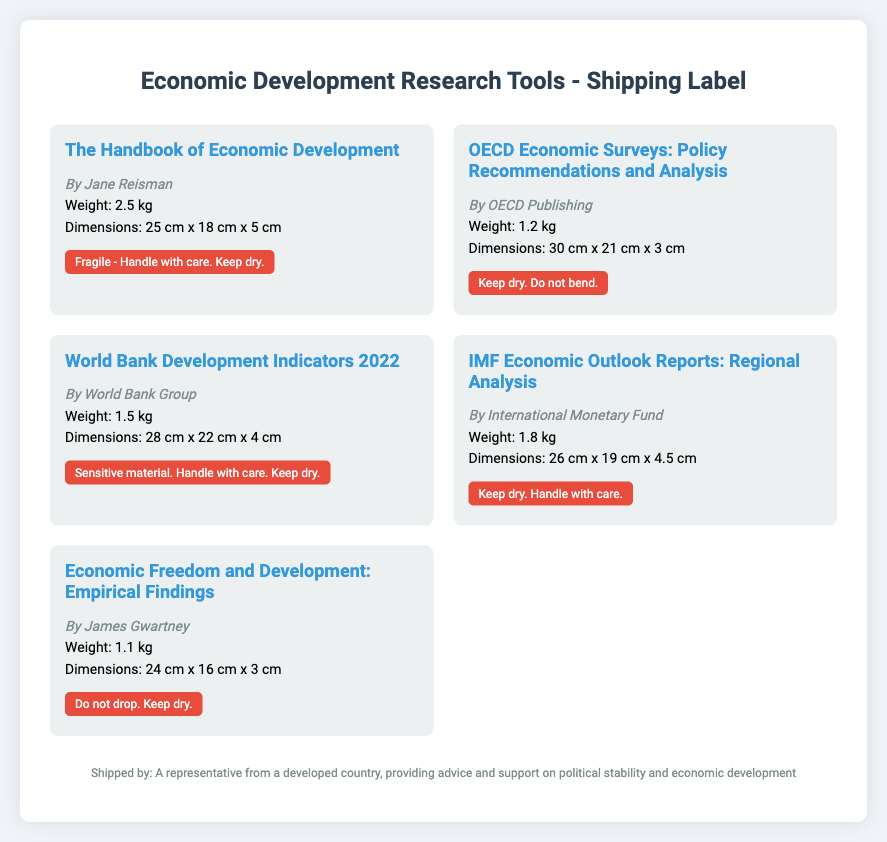What is the weight of "The Handbook of Economic Development"? The weight is specifically listed in the document under the material for "The Handbook of Economic Development."
Answer: 2.5 kg What are the dimensions of the "OECD Economic Surveys"? The dimensions are provided in the document, detailing the size of the "OECD Economic Surveys."
Answer: 30 cm x 21 cm x 3 cm Who authored the "World Bank Development Indicators 2022"? The author is mentioned in the material description for the "World Bank Development Indicators 2022."
Answer: World Bank Group What special handling instructions are indicated for the "IMF Economic Outlook Reports"? The special handling instructions are listed under the material for the "IMF Economic Outlook Reports."
Answer: Keep dry. Handle with care What is the total weight of all materials listed? The total weight is the sum of all individual weights specified in the document for each material.
Answer: 8.1 kg Which material has the lightest weight? The weight of each material is provided, enabling identification of the lightest one.
Answer: Economic Freedom and Development: Empirical Findings What is the special instruction for "The Handbook of Economic Development"? Special instructions for handling are explicitly mentioned in the document for that material.
Answer: Fragile - Handle with care. Keep dry What is the author of "Economic Freedom and Development: Empirical Findings"? The author is noted in the corresponding material section for that title.
Answer: James Gwartney What is the dimension of "World Bank Development Indicators 2022"? Dimensions are detailed in the material description for that specific item.
Answer: 28 cm x 22 cm x 4 cm 